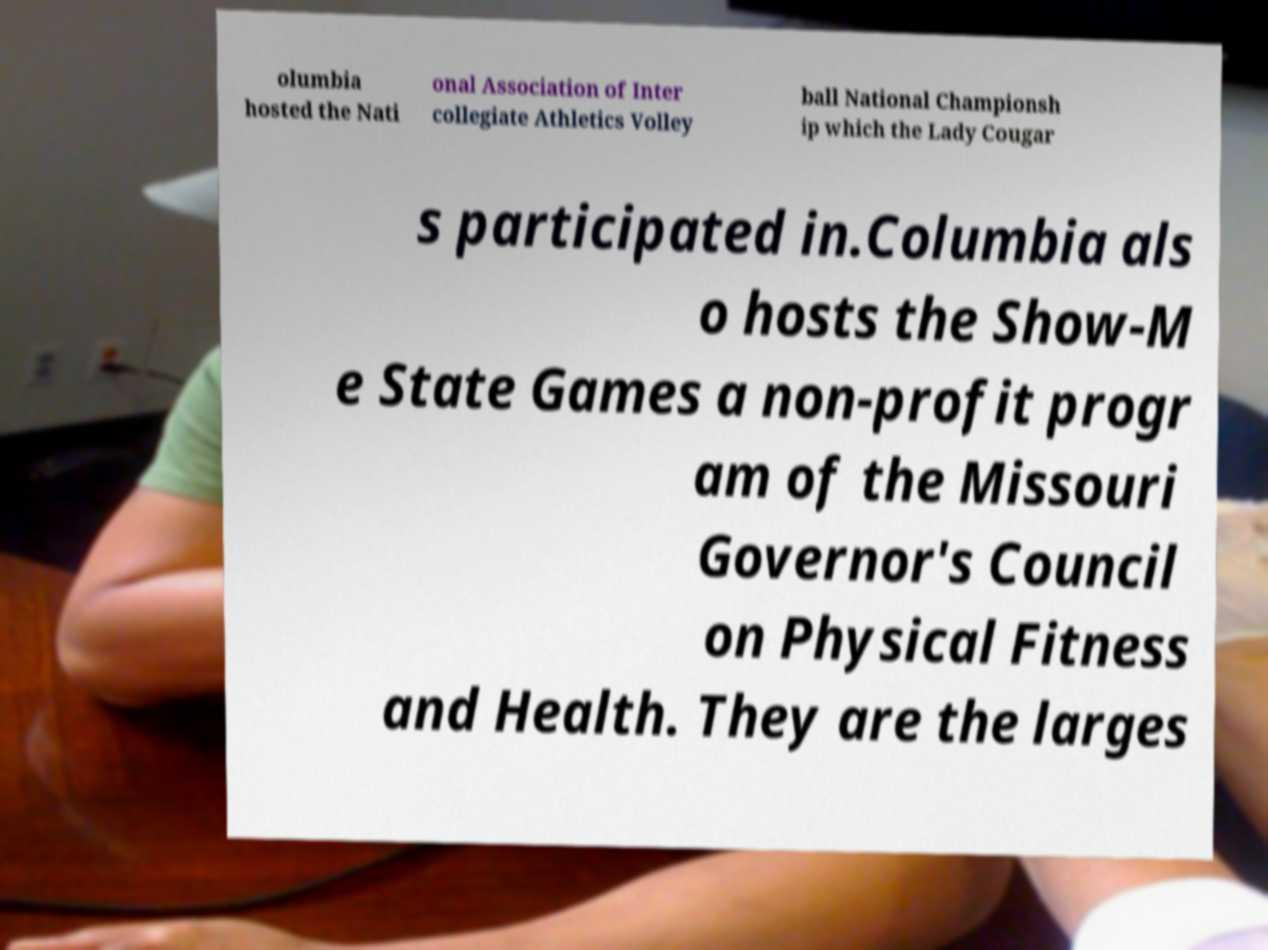What messages or text are displayed in this image? I need them in a readable, typed format. olumbia hosted the Nati onal Association of Inter collegiate Athletics Volley ball National Championsh ip which the Lady Cougar s participated in.Columbia als o hosts the Show-M e State Games a non-profit progr am of the Missouri Governor's Council on Physical Fitness and Health. They are the larges 